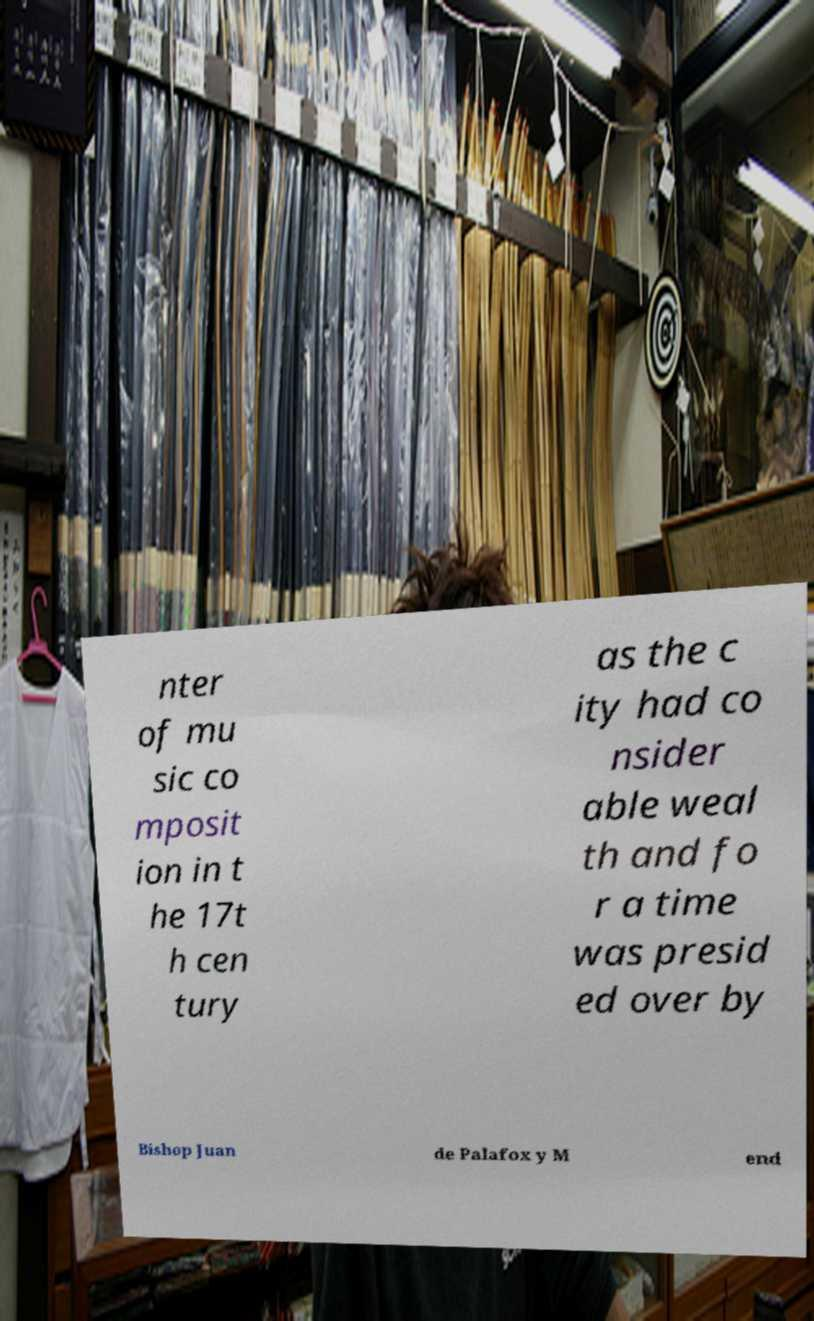For documentation purposes, I need the text within this image transcribed. Could you provide that? nter of mu sic co mposit ion in t he 17t h cen tury as the c ity had co nsider able weal th and fo r a time was presid ed over by Bishop Juan de Palafox y M end 